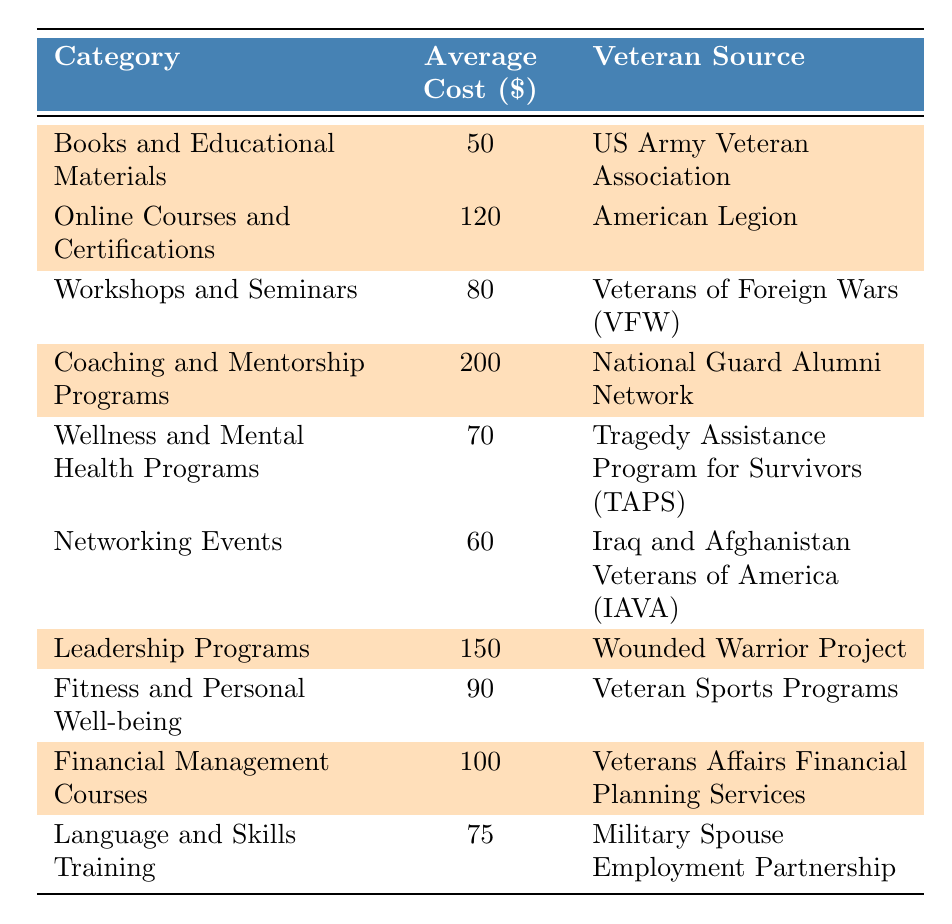What is the average cost of Online Courses and Certifications? The average cost for Online Courses and Certifications is listed in the table as 120.
Answer: 120 Which category has the highest average cost? By reviewing the table, Coaching and Mentorship Programs has the highest average cost at 200.
Answer: Coaching and Mentorship Programs How much do Books and Educational Materials cost on average compared to Networking Events? The average cost of Books and Educational Materials is 50, and for Networking Events, it is 60. Therefore, Books and Educational Materials cost 10 less than Networking Events.
Answer: Books and Educational Materials are 10 less Is there a category less than $70 in expenditure? The only category that is less than $70 is Books and Educational Materials, which costs 50.
Answer: Yes What is the total of the average costs for the highlighted categories? The highlighted categories and their costs are: 50 (Books) + 120 (Courses) + 200 (Coaching) + 150 (Leadership) + 100 (Financial Management) = 720.
Answer: 720 How many highlighted categories have an average cost above $100? The highlighted categories above $100 are Online Courses (120), Coaching (200), Leadership (150), and Financial Management (100). There are 3 of them above $100.
Answer: 3 What is the difference in average cost between Coaching and Mentorship Programs and Wellness and Mental Health Programs? The average cost for Coaching and Mentorship Programs is 200, and for Wellness and Mental Health Programs, it is 70. The difference is 200 - 70 = 130.
Answer: 130 Which veteran source corresponds to the category with the lowest average cost? The category with the lowest average cost is Books and Educational Materials at 50, and the corresponding veteran source is the US Army Veteran Association.
Answer: US Army Veteran Association What is the average cost of the categories that are not highlighted? The non-highlighted categories and their costs are: 80 (Workshops) + 70 (Wellness) + 60 (Networking) + 90 (Fitness) + 75 (Language) = 375. There are 5 categories, so the average is 375/5 = 75.
Answer: 75 